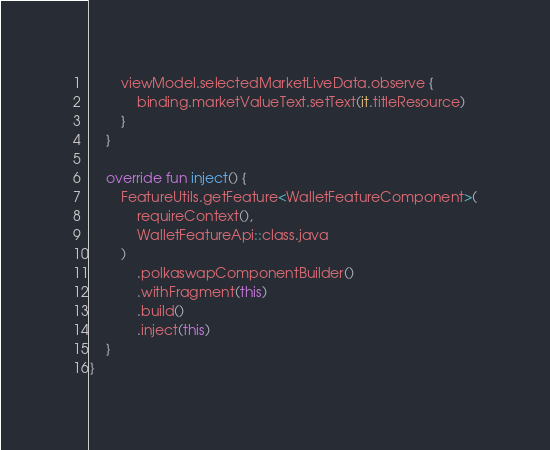<code> <loc_0><loc_0><loc_500><loc_500><_Kotlin_>
        viewModel.selectedMarketLiveData.observe {
            binding.marketValueText.setText(it.titleResource)
        }
    }

    override fun inject() {
        FeatureUtils.getFeature<WalletFeatureComponent>(
            requireContext(),
            WalletFeatureApi::class.java
        )
            .polkaswapComponentBuilder()
            .withFragment(this)
            .build()
            .inject(this)
    }
}
</code> 